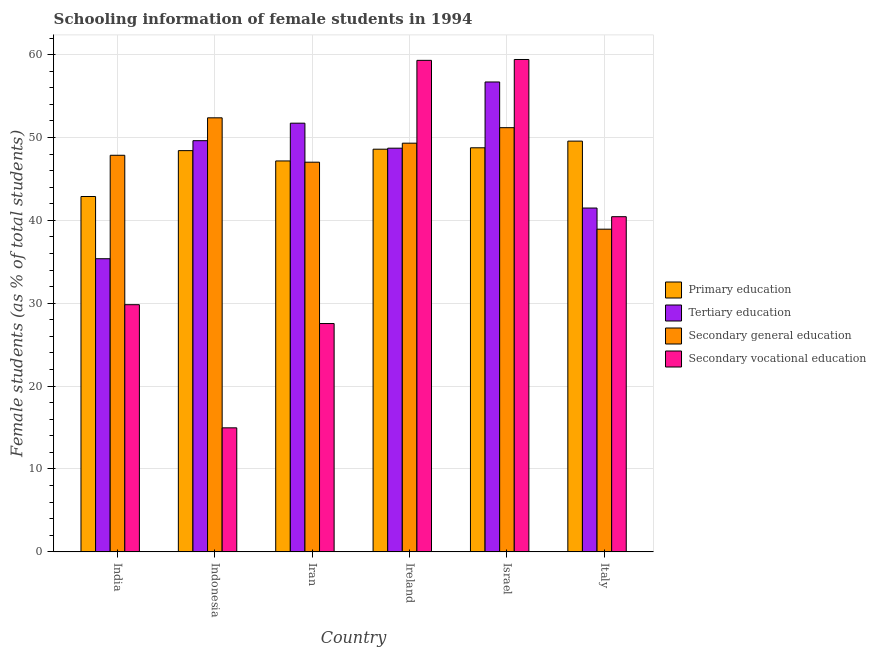How many groups of bars are there?
Offer a very short reply. 6. How many bars are there on the 2nd tick from the left?
Offer a terse response. 4. How many bars are there on the 6th tick from the right?
Offer a terse response. 4. In how many cases, is the number of bars for a given country not equal to the number of legend labels?
Keep it short and to the point. 0. What is the percentage of female students in primary education in Iran?
Your answer should be very brief. 47.17. Across all countries, what is the maximum percentage of female students in secondary vocational education?
Give a very brief answer. 59.41. Across all countries, what is the minimum percentage of female students in primary education?
Make the answer very short. 42.88. In which country was the percentage of female students in tertiary education minimum?
Provide a succinct answer. India. What is the total percentage of female students in primary education in the graph?
Ensure brevity in your answer.  285.38. What is the difference between the percentage of female students in tertiary education in Iran and that in Israel?
Keep it short and to the point. -4.97. What is the difference between the percentage of female students in tertiary education in Indonesia and the percentage of female students in secondary vocational education in Ireland?
Offer a very short reply. -9.69. What is the average percentage of female students in secondary education per country?
Make the answer very short. 47.78. What is the difference between the percentage of female students in tertiary education and percentage of female students in secondary education in Iran?
Offer a very short reply. 4.71. What is the ratio of the percentage of female students in secondary vocational education in Israel to that in Italy?
Your answer should be very brief. 1.47. What is the difference between the highest and the second highest percentage of female students in secondary vocational education?
Your response must be concise. 0.1. What is the difference between the highest and the lowest percentage of female students in tertiary education?
Give a very brief answer. 21.33. In how many countries, is the percentage of female students in secondary vocational education greater than the average percentage of female students in secondary vocational education taken over all countries?
Your answer should be very brief. 3. Is it the case that in every country, the sum of the percentage of female students in tertiary education and percentage of female students in primary education is greater than the sum of percentage of female students in secondary education and percentage of female students in secondary vocational education?
Your response must be concise. No. What does the 3rd bar from the left in India represents?
Offer a very short reply. Secondary general education. What does the 2nd bar from the right in Indonesia represents?
Your answer should be very brief. Secondary general education. Is it the case that in every country, the sum of the percentage of female students in primary education and percentage of female students in tertiary education is greater than the percentage of female students in secondary education?
Your response must be concise. Yes. Are all the bars in the graph horizontal?
Offer a terse response. No. How many countries are there in the graph?
Keep it short and to the point. 6. What is the difference between two consecutive major ticks on the Y-axis?
Offer a very short reply. 10. Are the values on the major ticks of Y-axis written in scientific E-notation?
Your answer should be compact. No. Does the graph contain any zero values?
Make the answer very short. No. How many legend labels are there?
Provide a succinct answer. 4. What is the title of the graph?
Your answer should be compact. Schooling information of female students in 1994. What is the label or title of the X-axis?
Make the answer very short. Country. What is the label or title of the Y-axis?
Keep it short and to the point. Female students (as % of total students). What is the Female students (as % of total students) of Primary education in India?
Ensure brevity in your answer.  42.88. What is the Female students (as % of total students) in Tertiary education in India?
Offer a very short reply. 35.37. What is the Female students (as % of total students) in Secondary general education in India?
Offer a terse response. 47.86. What is the Female students (as % of total students) in Secondary vocational education in India?
Keep it short and to the point. 29.83. What is the Female students (as % of total students) in Primary education in Indonesia?
Offer a very short reply. 48.42. What is the Female students (as % of total students) in Tertiary education in Indonesia?
Give a very brief answer. 49.62. What is the Female students (as % of total students) of Secondary general education in Indonesia?
Provide a short and direct response. 52.38. What is the Female students (as % of total students) of Secondary vocational education in Indonesia?
Your response must be concise. 14.97. What is the Female students (as % of total students) of Primary education in Iran?
Offer a terse response. 47.17. What is the Female students (as % of total students) in Tertiary education in Iran?
Provide a short and direct response. 51.73. What is the Female students (as % of total students) in Secondary general education in Iran?
Your answer should be very brief. 47.02. What is the Female students (as % of total students) in Secondary vocational education in Iran?
Provide a short and direct response. 27.55. What is the Female students (as % of total students) of Primary education in Ireland?
Offer a very short reply. 48.59. What is the Female students (as % of total students) in Tertiary education in Ireland?
Offer a terse response. 48.71. What is the Female students (as % of total students) of Secondary general education in Ireland?
Make the answer very short. 49.31. What is the Female students (as % of total students) in Secondary vocational education in Ireland?
Your answer should be compact. 59.31. What is the Female students (as % of total students) in Primary education in Israel?
Ensure brevity in your answer.  48.76. What is the Female students (as % of total students) of Tertiary education in Israel?
Keep it short and to the point. 56.7. What is the Female students (as % of total students) of Secondary general education in Israel?
Provide a short and direct response. 51.18. What is the Female students (as % of total students) in Secondary vocational education in Israel?
Offer a terse response. 59.41. What is the Female students (as % of total students) of Primary education in Italy?
Provide a succinct answer. 49.56. What is the Female students (as % of total students) of Tertiary education in Italy?
Your answer should be compact. 41.49. What is the Female students (as % of total students) of Secondary general education in Italy?
Provide a short and direct response. 38.94. What is the Female students (as % of total students) of Secondary vocational education in Italy?
Keep it short and to the point. 40.44. Across all countries, what is the maximum Female students (as % of total students) in Primary education?
Make the answer very short. 49.56. Across all countries, what is the maximum Female students (as % of total students) in Tertiary education?
Offer a very short reply. 56.7. Across all countries, what is the maximum Female students (as % of total students) of Secondary general education?
Your answer should be compact. 52.38. Across all countries, what is the maximum Female students (as % of total students) in Secondary vocational education?
Your answer should be compact. 59.41. Across all countries, what is the minimum Female students (as % of total students) in Primary education?
Offer a terse response. 42.88. Across all countries, what is the minimum Female students (as % of total students) in Tertiary education?
Keep it short and to the point. 35.37. Across all countries, what is the minimum Female students (as % of total students) of Secondary general education?
Provide a succinct answer. 38.94. Across all countries, what is the minimum Female students (as % of total students) in Secondary vocational education?
Your answer should be very brief. 14.97. What is the total Female students (as % of total students) of Primary education in the graph?
Offer a terse response. 285.38. What is the total Female students (as % of total students) in Tertiary education in the graph?
Provide a short and direct response. 283.62. What is the total Female students (as % of total students) of Secondary general education in the graph?
Keep it short and to the point. 286.69. What is the total Female students (as % of total students) in Secondary vocational education in the graph?
Your answer should be very brief. 231.51. What is the difference between the Female students (as % of total students) in Primary education in India and that in Indonesia?
Your answer should be compact. -5.54. What is the difference between the Female students (as % of total students) in Tertiary education in India and that in Indonesia?
Give a very brief answer. -14.24. What is the difference between the Female students (as % of total students) of Secondary general education in India and that in Indonesia?
Provide a succinct answer. -4.52. What is the difference between the Female students (as % of total students) of Secondary vocational education in India and that in Indonesia?
Provide a short and direct response. 14.86. What is the difference between the Female students (as % of total students) in Primary education in India and that in Iran?
Give a very brief answer. -4.29. What is the difference between the Female students (as % of total students) in Tertiary education in India and that in Iran?
Offer a very short reply. -16.36. What is the difference between the Female students (as % of total students) of Secondary general education in India and that in Iran?
Offer a very short reply. 0.84. What is the difference between the Female students (as % of total students) of Secondary vocational education in India and that in Iran?
Ensure brevity in your answer.  2.27. What is the difference between the Female students (as % of total students) of Primary education in India and that in Ireland?
Provide a succinct answer. -5.71. What is the difference between the Female students (as % of total students) in Tertiary education in India and that in Ireland?
Ensure brevity in your answer.  -13.34. What is the difference between the Female students (as % of total students) of Secondary general education in India and that in Ireland?
Ensure brevity in your answer.  -1.46. What is the difference between the Female students (as % of total students) of Secondary vocational education in India and that in Ireland?
Give a very brief answer. -29.48. What is the difference between the Female students (as % of total students) in Primary education in India and that in Israel?
Your answer should be very brief. -5.88. What is the difference between the Female students (as % of total students) in Tertiary education in India and that in Israel?
Provide a short and direct response. -21.33. What is the difference between the Female students (as % of total students) in Secondary general education in India and that in Israel?
Offer a terse response. -3.33. What is the difference between the Female students (as % of total students) in Secondary vocational education in India and that in Israel?
Make the answer very short. -29.59. What is the difference between the Female students (as % of total students) in Primary education in India and that in Italy?
Offer a very short reply. -6.68. What is the difference between the Female students (as % of total students) in Tertiary education in India and that in Italy?
Keep it short and to the point. -6.12. What is the difference between the Female students (as % of total students) of Secondary general education in India and that in Italy?
Keep it short and to the point. 8.92. What is the difference between the Female students (as % of total students) in Secondary vocational education in India and that in Italy?
Offer a very short reply. -10.62. What is the difference between the Female students (as % of total students) of Primary education in Indonesia and that in Iran?
Give a very brief answer. 1.24. What is the difference between the Female students (as % of total students) of Tertiary education in Indonesia and that in Iran?
Give a very brief answer. -2.11. What is the difference between the Female students (as % of total students) in Secondary general education in Indonesia and that in Iran?
Your answer should be compact. 5.36. What is the difference between the Female students (as % of total students) in Secondary vocational education in Indonesia and that in Iran?
Provide a short and direct response. -12.59. What is the difference between the Female students (as % of total students) in Primary education in Indonesia and that in Ireland?
Offer a very short reply. -0.17. What is the difference between the Female students (as % of total students) of Tertiary education in Indonesia and that in Ireland?
Offer a terse response. 0.9. What is the difference between the Female students (as % of total students) in Secondary general education in Indonesia and that in Ireland?
Provide a succinct answer. 3.06. What is the difference between the Female students (as % of total students) of Secondary vocational education in Indonesia and that in Ireland?
Your answer should be very brief. -44.34. What is the difference between the Female students (as % of total students) in Primary education in Indonesia and that in Israel?
Provide a short and direct response. -0.34. What is the difference between the Female students (as % of total students) in Tertiary education in Indonesia and that in Israel?
Your answer should be compact. -7.08. What is the difference between the Female students (as % of total students) in Secondary general education in Indonesia and that in Israel?
Your response must be concise. 1.19. What is the difference between the Female students (as % of total students) in Secondary vocational education in Indonesia and that in Israel?
Make the answer very short. -44.45. What is the difference between the Female students (as % of total students) in Primary education in Indonesia and that in Italy?
Ensure brevity in your answer.  -1.15. What is the difference between the Female students (as % of total students) of Tertiary education in Indonesia and that in Italy?
Your answer should be compact. 8.13. What is the difference between the Female students (as % of total students) of Secondary general education in Indonesia and that in Italy?
Your answer should be very brief. 13.44. What is the difference between the Female students (as % of total students) in Secondary vocational education in Indonesia and that in Italy?
Provide a succinct answer. -25.48. What is the difference between the Female students (as % of total students) of Primary education in Iran and that in Ireland?
Your answer should be very brief. -1.42. What is the difference between the Female students (as % of total students) in Tertiary education in Iran and that in Ireland?
Ensure brevity in your answer.  3.02. What is the difference between the Female students (as % of total students) of Secondary general education in Iran and that in Ireland?
Your answer should be very brief. -2.29. What is the difference between the Female students (as % of total students) of Secondary vocational education in Iran and that in Ireland?
Your answer should be compact. -31.76. What is the difference between the Female students (as % of total students) in Primary education in Iran and that in Israel?
Keep it short and to the point. -1.59. What is the difference between the Female students (as % of total students) in Tertiary education in Iran and that in Israel?
Provide a succinct answer. -4.97. What is the difference between the Female students (as % of total students) of Secondary general education in Iran and that in Israel?
Your response must be concise. -4.16. What is the difference between the Female students (as % of total students) in Secondary vocational education in Iran and that in Israel?
Ensure brevity in your answer.  -31.86. What is the difference between the Female students (as % of total students) in Primary education in Iran and that in Italy?
Your answer should be compact. -2.39. What is the difference between the Female students (as % of total students) of Tertiary education in Iran and that in Italy?
Ensure brevity in your answer.  10.24. What is the difference between the Female students (as % of total students) in Secondary general education in Iran and that in Italy?
Your response must be concise. 8.08. What is the difference between the Female students (as % of total students) in Secondary vocational education in Iran and that in Italy?
Make the answer very short. -12.89. What is the difference between the Female students (as % of total students) in Primary education in Ireland and that in Israel?
Make the answer very short. -0.17. What is the difference between the Female students (as % of total students) in Tertiary education in Ireland and that in Israel?
Your response must be concise. -7.99. What is the difference between the Female students (as % of total students) in Secondary general education in Ireland and that in Israel?
Give a very brief answer. -1.87. What is the difference between the Female students (as % of total students) in Secondary vocational education in Ireland and that in Israel?
Provide a short and direct response. -0.1. What is the difference between the Female students (as % of total students) in Primary education in Ireland and that in Italy?
Ensure brevity in your answer.  -0.97. What is the difference between the Female students (as % of total students) of Tertiary education in Ireland and that in Italy?
Keep it short and to the point. 7.22. What is the difference between the Female students (as % of total students) in Secondary general education in Ireland and that in Italy?
Your answer should be very brief. 10.38. What is the difference between the Female students (as % of total students) of Secondary vocational education in Ireland and that in Italy?
Keep it short and to the point. 18.86. What is the difference between the Female students (as % of total students) in Primary education in Israel and that in Italy?
Give a very brief answer. -0.81. What is the difference between the Female students (as % of total students) of Tertiary education in Israel and that in Italy?
Offer a very short reply. 15.21. What is the difference between the Female students (as % of total students) in Secondary general education in Israel and that in Italy?
Ensure brevity in your answer.  12.25. What is the difference between the Female students (as % of total students) of Secondary vocational education in Israel and that in Italy?
Your answer should be very brief. 18.97. What is the difference between the Female students (as % of total students) in Primary education in India and the Female students (as % of total students) in Tertiary education in Indonesia?
Ensure brevity in your answer.  -6.74. What is the difference between the Female students (as % of total students) in Primary education in India and the Female students (as % of total students) in Secondary general education in Indonesia?
Provide a succinct answer. -9.5. What is the difference between the Female students (as % of total students) in Primary education in India and the Female students (as % of total students) in Secondary vocational education in Indonesia?
Offer a terse response. 27.91. What is the difference between the Female students (as % of total students) in Tertiary education in India and the Female students (as % of total students) in Secondary general education in Indonesia?
Your answer should be compact. -17. What is the difference between the Female students (as % of total students) in Tertiary education in India and the Female students (as % of total students) in Secondary vocational education in Indonesia?
Make the answer very short. 20.41. What is the difference between the Female students (as % of total students) in Secondary general education in India and the Female students (as % of total students) in Secondary vocational education in Indonesia?
Offer a very short reply. 32.89. What is the difference between the Female students (as % of total students) of Primary education in India and the Female students (as % of total students) of Tertiary education in Iran?
Ensure brevity in your answer.  -8.85. What is the difference between the Female students (as % of total students) in Primary education in India and the Female students (as % of total students) in Secondary general education in Iran?
Ensure brevity in your answer.  -4.14. What is the difference between the Female students (as % of total students) in Primary education in India and the Female students (as % of total students) in Secondary vocational education in Iran?
Keep it short and to the point. 15.33. What is the difference between the Female students (as % of total students) of Tertiary education in India and the Female students (as % of total students) of Secondary general education in Iran?
Ensure brevity in your answer.  -11.65. What is the difference between the Female students (as % of total students) of Tertiary education in India and the Female students (as % of total students) of Secondary vocational education in Iran?
Make the answer very short. 7.82. What is the difference between the Female students (as % of total students) in Secondary general education in India and the Female students (as % of total students) in Secondary vocational education in Iran?
Provide a short and direct response. 20.3. What is the difference between the Female students (as % of total students) of Primary education in India and the Female students (as % of total students) of Tertiary education in Ireland?
Offer a terse response. -5.83. What is the difference between the Female students (as % of total students) of Primary education in India and the Female students (as % of total students) of Secondary general education in Ireland?
Offer a terse response. -6.43. What is the difference between the Female students (as % of total students) of Primary education in India and the Female students (as % of total students) of Secondary vocational education in Ireland?
Provide a short and direct response. -16.43. What is the difference between the Female students (as % of total students) of Tertiary education in India and the Female students (as % of total students) of Secondary general education in Ireland?
Your answer should be compact. -13.94. What is the difference between the Female students (as % of total students) of Tertiary education in India and the Female students (as % of total students) of Secondary vocational education in Ireland?
Provide a succinct answer. -23.94. What is the difference between the Female students (as % of total students) in Secondary general education in India and the Female students (as % of total students) in Secondary vocational education in Ireland?
Keep it short and to the point. -11.45. What is the difference between the Female students (as % of total students) of Primary education in India and the Female students (as % of total students) of Tertiary education in Israel?
Offer a terse response. -13.82. What is the difference between the Female students (as % of total students) in Primary education in India and the Female students (as % of total students) in Secondary general education in Israel?
Provide a short and direct response. -8.3. What is the difference between the Female students (as % of total students) of Primary education in India and the Female students (as % of total students) of Secondary vocational education in Israel?
Provide a succinct answer. -16.53. What is the difference between the Female students (as % of total students) of Tertiary education in India and the Female students (as % of total students) of Secondary general education in Israel?
Provide a succinct answer. -15.81. What is the difference between the Female students (as % of total students) in Tertiary education in India and the Female students (as % of total students) in Secondary vocational education in Israel?
Keep it short and to the point. -24.04. What is the difference between the Female students (as % of total students) of Secondary general education in India and the Female students (as % of total students) of Secondary vocational education in Israel?
Ensure brevity in your answer.  -11.56. What is the difference between the Female students (as % of total students) in Primary education in India and the Female students (as % of total students) in Tertiary education in Italy?
Provide a short and direct response. 1.39. What is the difference between the Female students (as % of total students) of Primary education in India and the Female students (as % of total students) of Secondary general education in Italy?
Your response must be concise. 3.94. What is the difference between the Female students (as % of total students) of Primary education in India and the Female students (as % of total students) of Secondary vocational education in Italy?
Your answer should be compact. 2.44. What is the difference between the Female students (as % of total students) in Tertiary education in India and the Female students (as % of total students) in Secondary general education in Italy?
Provide a succinct answer. -3.56. What is the difference between the Female students (as % of total students) in Tertiary education in India and the Female students (as % of total students) in Secondary vocational education in Italy?
Make the answer very short. -5.07. What is the difference between the Female students (as % of total students) in Secondary general education in India and the Female students (as % of total students) in Secondary vocational education in Italy?
Offer a terse response. 7.41. What is the difference between the Female students (as % of total students) of Primary education in Indonesia and the Female students (as % of total students) of Tertiary education in Iran?
Offer a very short reply. -3.31. What is the difference between the Female students (as % of total students) of Primary education in Indonesia and the Female students (as % of total students) of Secondary general education in Iran?
Provide a short and direct response. 1.4. What is the difference between the Female students (as % of total students) of Primary education in Indonesia and the Female students (as % of total students) of Secondary vocational education in Iran?
Offer a terse response. 20.86. What is the difference between the Female students (as % of total students) in Tertiary education in Indonesia and the Female students (as % of total students) in Secondary general education in Iran?
Your response must be concise. 2.6. What is the difference between the Female students (as % of total students) in Tertiary education in Indonesia and the Female students (as % of total students) in Secondary vocational education in Iran?
Ensure brevity in your answer.  22.06. What is the difference between the Female students (as % of total students) in Secondary general education in Indonesia and the Female students (as % of total students) in Secondary vocational education in Iran?
Give a very brief answer. 24.82. What is the difference between the Female students (as % of total students) in Primary education in Indonesia and the Female students (as % of total students) in Tertiary education in Ireland?
Give a very brief answer. -0.3. What is the difference between the Female students (as % of total students) of Primary education in Indonesia and the Female students (as % of total students) of Secondary general education in Ireland?
Your answer should be very brief. -0.9. What is the difference between the Female students (as % of total students) in Primary education in Indonesia and the Female students (as % of total students) in Secondary vocational education in Ireland?
Offer a terse response. -10.89. What is the difference between the Female students (as % of total students) of Tertiary education in Indonesia and the Female students (as % of total students) of Secondary general education in Ireland?
Provide a succinct answer. 0.3. What is the difference between the Female students (as % of total students) in Tertiary education in Indonesia and the Female students (as % of total students) in Secondary vocational education in Ireland?
Keep it short and to the point. -9.69. What is the difference between the Female students (as % of total students) in Secondary general education in Indonesia and the Female students (as % of total students) in Secondary vocational education in Ireland?
Provide a short and direct response. -6.93. What is the difference between the Female students (as % of total students) of Primary education in Indonesia and the Female students (as % of total students) of Tertiary education in Israel?
Make the answer very short. -8.28. What is the difference between the Female students (as % of total students) of Primary education in Indonesia and the Female students (as % of total students) of Secondary general education in Israel?
Your response must be concise. -2.77. What is the difference between the Female students (as % of total students) of Primary education in Indonesia and the Female students (as % of total students) of Secondary vocational education in Israel?
Your response must be concise. -11. What is the difference between the Female students (as % of total students) of Tertiary education in Indonesia and the Female students (as % of total students) of Secondary general education in Israel?
Your answer should be compact. -1.57. What is the difference between the Female students (as % of total students) in Tertiary education in Indonesia and the Female students (as % of total students) in Secondary vocational education in Israel?
Offer a terse response. -9.8. What is the difference between the Female students (as % of total students) of Secondary general education in Indonesia and the Female students (as % of total students) of Secondary vocational education in Israel?
Provide a succinct answer. -7.04. What is the difference between the Female students (as % of total students) in Primary education in Indonesia and the Female students (as % of total students) in Tertiary education in Italy?
Keep it short and to the point. 6.93. What is the difference between the Female students (as % of total students) in Primary education in Indonesia and the Female students (as % of total students) in Secondary general education in Italy?
Your response must be concise. 9.48. What is the difference between the Female students (as % of total students) of Primary education in Indonesia and the Female students (as % of total students) of Secondary vocational education in Italy?
Keep it short and to the point. 7.97. What is the difference between the Female students (as % of total students) in Tertiary education in Indonesia and the Female students (as % of total students) in Secondary general education in Italy?
Provide a succinct answer. 10.68. What is the difference between the Female students (as % of total students) in Tertiary education in Indonesia and the Female students (as % of total students) in Secondary vocational education in Italy?
Your response must be concise. 9.17. What is the difference between the Female students (as % of total students) of Secondary general education in Indonesia and the Female students (as % of total students) of Secondary vocational education in Italy?
Give a very brief answer. 11.93. What is the difference between the Female students (as % of total students) of Primary education in Iran and the Female students (as % of total students) of Tertiary education in Ireland?
Your answer should be compact. -1.54. What is the difference between the Female students (as % of total students) in Primary education in Iran and the Female students (as % of total students) in Secondary general education in Ireland?
Ensure brevity in your answer.  -2.14. What is the difference between the Female students (as % of total students) of Primary education in Iran and the Female students (as % of total students) of Secondary vocational education in Ireland?
Offer a terse response. -12.14. What is the difference between the Female students (as % of total students) in Tertiary education in Iran and the Female students (as % of total students) in Secondary general education in Ireland?
Offer a very short reply. 2.41. What is the difference between the Female students (as % of total students) in Tertiary education in Iran and the Female students (as % of total students) in Secondary vocational education in Ireland?
Provide a succinct answer. -7.58. What is the difference between the Female students (as % of total students) of Secondary general education in Iran and the Female students (as % of total students) of Secondary vocational education in Ireland?
Provide a succinct answer. -12.29. What is the difference between the Female students (as % of total students) in Primary education in Iran and the Female students (as % of total students) in Tertiary education in Israel?
Your answer should be compact. -9.53. What is the difference between the Female students (as % of total students) of Primary education in Iran and the Female students (as % of total students) of Secondary general education in Israel?
Keep it short and to the point. -4.01. What is the difference between the Female students (as % of total students) of Primary education in Iran and the Female students (as % of total students) of Secondary vocational education in Israel?
Provide a short and direct response. -12.24. What is the difference between the Female students (as % of total students) of Tertiary education in Iran and the Female students (as % of total students) of Secondary general education in Israel?
Provide a succinct answer. 0.54. What is the difference between the Female students (as % of total students) in Tertiary education in Iran and the Female students (as % of total students) in Secondary vocational education in Israel?
Ensure brevity in your answer.  -7.68. What is the difference between the Female students (as % of total students) of Secondary general education in Iran and the Female students (as % of total students) of Secondary vocational education in Israel?
Your answer should be very brief. -12.39. What is the difference between the Female students (as % of total students) of Primary education in Iran and the Female students (as % of total students) of Tertiary education in Italy?
Your answer should be very brief. 5.68. What is the difference between the Female students (as % of total students) of Primary education in Iran and the Female students (as % of total students) of Secondary general education in Italy?
Offer a very short reply. 8.23. What is the difference between the Female students (as % of total students) of Primary education in Iran and the Female students (as % of total students) of Secondary vocational education in Italy?
Your answer should be compact. 6.73. What is the difference between the Female students (as % of total students) in Tertiary education in Iran and the Female students (as % of total students) in Secondary general education in Italy?
Provide a succinct answer. 12.79. What is the difference between the Female students (as % of total students) of Tertiary education in Iran and the Female students (as % of total students) of Secondary vocational education in Italy?
Your answer should be very brief. 11.28. What is the difference between the Female students (as % of total students) of Secondary general education in Iran and the Female students (as % of total students) of Secondary vocational education in Italy?
Make the answer very short. 6.58. What is the difference between the Female students (as % of total students) in Primary education in Ireland and the Female students (as % of total students) in Tertiary education in Israel?
Your answer should be very brief. -8.11. What is the difference between the Female students (as % of total students) in Primary education in Ireland and the Female students (as % of total students) in Secondary general education in Israel?
Provide a short and direct response. -2.6. What is the difference between the Female students (as % of total students) of Primary education in Ireland and the Female students (as % of total students) of Secondary vocational education in Israel?
Provide a succinct answer. -10.82. What is the difference between the Female students (as % of total students) of Tertiary education in Ireland and the Female students (as % of total students) of Secondary general education in Israel?
Make the answer very short. -2.47. What is the difference between the Female students (as % of total students) of Tertiary education in Ireland and the Female students (as % of total students) of Secondary vocational education in Israel?
Your answer should be compact. -10.7. What is the difference between the Female students (as % of total students) in Secondary general education in Ireland and the Female students (as % of total students) in Secondary vocational education in Israel?
Your answer should be compact. -10.1. What is the difference between the Female students (as % of total students) of Primary education in Ireland and the Female students (as % of total students) of Tertiary education in Italy?
Your answer should be compact. 7.1. What is the difference between the Female students (as % of total students) of Primary education in Ireland and the Female students (as % of total students) of Secondary general education in Italy?
Offer a terse response. 9.65. What is the difference between the Female students (as % of total students) in Primary education in Ireland and the Female students (as % of total students) in Secondary vocational education in Italy?
Your response must be concise. 8.14. What is the difference between the Female students (as % of total students) in Tertiary education in Ireland and the Female students (as % of total students) in Secondary general education in Italy?
Your response must be concise. 9.78. What is the difference between the Female students (as % of total students) in Tertiary education in Ireland and the Female students (as % of total students) in Secondary vocational education in Italy?
Offer a terse response. 8.27. What is the difference between the Female students (as % of total students) in Secondary general education in Ireland and the Female students (as % of total students) in Secondary vocational education in Italy?
Make the answer very short. 8.87. What is the difference between the Female students (as % of total students) of Primary education in Israel and the Female students (as % of total students) of Tertiary education in Italy?
Make the answer very short. 7.27. What is the difference between the Female students (as % of total students) of Primary education in Israel and the Female students (as % of total students) of Secondary general education in Italy?
Your answer should be very brief. 9.82. What is the difference between the Female students (as % of total students) in Primary education in Israel and the Female students (as % of total students) in Secondary vocational education in Italy?
Your answer should be very brief. 8.31. What is the difference between the Female students (as % of total students) in Tertiary education in Israel and the Female students (as % of total students) in Secondary general education in Italy?
Keep it short and to the point. 17.76. What is the difference between the Female students (as % of total students) of Tertiary education in Israel and the Female students (as % of total students) of Secondary vocational education in Italy?
Provide a succinct answer. 16.25. What is the difference between the Female students (as % of total students) of Secondary general education in Israel and the Female students (as % of total students) of Secondary vocational education in Italy?
Your response must be concise. 10.74. What is the average Female students (as % of total students) of Primary education per country?
Offer a terse response. 47.56. What is the average Female students (as % of total students) in Tertiary education per country?
Ensure brevity in your answer.  47.27. What is the average Female students (as % of total students) of Secondary general education per country?
Offer a very short reply. 47.78. What is the average Female students (as % of total students) in Secondary vocational education per country?
Ensure brevity in your answer.  38.59. What is the difference between the Female students (as % of total students) in Primary education and Female students (as % of total students) in Tertiary education in India?
Your answer should be very brief. 7.51. What is the difference between the Female students (as % of total students) of Primary education and Female students (as % of total students) of Secondary general education in India?
Give a very brief answer. -4.98. What is the difference between the Female students (as % of total students) of Primary education and Female students (as % of total students) of Secondary vocational education in India?
Offer a very short reply. 13.05. What is the difference between the Female students (as % of total students) in Tertiary education and Female students (as % of total students) in Secondary general education in India?
Ensure brevity in your answer.  -12.48. What is the difference between the Female students (as % of total students) in Tertiary education and Female students (as % of total students) in Secondary vocational education in India?
Make the answer very short. 5.55. What is the difference between the Female students (as % of total students) in Secondary general education and Female students (as % of total students) in Secondary vocational education in India?
Give a very brief answer. 18.03. What is the difference between the Female students (as % of total students) of Primary education and Female students (as % of total students) of Tertiary education in Indonesia?
Keep it short and to the point. -1.2. What is the difference between the Female students (as % of total students) in Primary education and Female students (as % of total students) in Secondary general education in Indonesia?
Ensure brevity in your answer.  -3.96. What is the difference between the Female students (as % of total students) in Primary education and Female students (as % of total students) in Secondary vocational education in Indonesia?
Your answer should be very brief. 33.45. What is the difference between the Female students (as % of total students) of Tertiary education and Female students (as % of total students) of Secondary general education in Indonesia?
Make the answer very short. -2.76. What is the difference between the Female students (as % of total students) in Tertiary education and Female students (as % of total students) in Secondary vocational education in Indonesia?
Offer a very short reply. 34.65. What is the difference between the Female students (as % of total students) of Secondary general education and Female students (as % of total students) of Secondary vocational education in Indonesia?
Ensure brevity in your answer.  37.41. What is the difference between the Female students (as % of total students) in Primary education and Female students (as % of total students) in Tertiary education in Iran?
Offer a very short reply. -4.56. What is the difference between the Female students (as % of total students) of Primary education and Female students (as % of total students) of Secondary general education in Iran?
Your response must be concise. 0.15. What is the difference between the Female students (as % of total students) of Primary education and Female students (as % of total students) of Secondary vocational education in Iran?
Provide a succinct answer. 19.62. What is the difference between the Female students (as % of total students) of Tertiary education and Female students (as % of total students) of Secondary general education in Iran?
Offer a very short reply. 4.71. What is the difference between the Female students (as % of total students) in Tertiary education and Female students (as % of total students) in Secondary vocational education in Iran?
Give a very brief answer. 24.18. What is the difference between the Female students (as % of total students) in Secondary general education and Female students (as % of total students) in Secondary vocational education in Iran?
Offer a very short reply. 19.47. What is the difference between the Female students (as % of total students) of Primary education and Female students (as % of total students) of Tertiary education in Ireland?
Your response must be concise. -0.12. What is the difference between the Female students (as % of total students) of Primary education and Female students (as % of total students) of Secondary general education in Ireland?
Your answer should be very brief. -0.73. What is the difference between the Female students (as % of total students) in Primary education and Female students (as % of total students) in Secondary vocational education in Ireland?
Offer a terse response. -10.72. What is the difference between the Female students (as % of total students) of Tertiary education and Female students (as % of total students) of Secondary general education in Ireland?
Provide a succinct answer. -0.6. What is the difference between the Female students (as % of total students) in Tertiary education and Female students (as % of total students) in Secondary vocational education in Ireland?
Ensure brevity in your answer.  -10.6. What is the difference between the Female students (as % of total students) in Secondary general education and Female students (as % of total students) in Secondary vocational education in Ireland?
Make the answer very short. -9.99. What is the difference between the Female students (as % of total students) of Primary education and Female students (as % of total students) of Tertiary education in Israel?
Ensure brevity in your answer.  -7.94. What is the difference between the Female students (as % of total students) in Primary education and Female students (as % of total students) in Secondary general education in Israel?
Provide a short and direct response. -2.43. What is the difference between the Female students (as % of total students) in Primary education and Female students (as % of total students) in Secondary vocational education in Israel?
Your answer should be compact. -10.65. What is the difference between the Female students (as % of total students) in Tertiary education and Female students (as % of total students) in Secondary general education in Israel?
Your answer should be very brief. 5.51. What is the difference between the Female students (as % of total students) in Tertiary education and Female students (as % of total students) in Secondary vocational education in Israel?
Provide a succinct answer. -2.71. What is the difference between the Female students (as % of total students) in Secondary general education and Female students (as % of total students) in Secondary vocational education in Israel?
Your answer should be compact. -8.23. What is the difference between the Female students (as % of total students) in Primary education and Female students (as % of total students) in Tertiary education in Italy?
Provide a succinct answer. 8.07. What is the difference between the Female students (as % of total students) of Primary education and Female students (as % of total students) of Secondary general education in Italy?
Your response must be concise. 10.63. What is the difference between the Female students (as % of total students) of Primary education and Female students (as % of total students) of Secondary vocational education in Italy?
Provide a short and direct response. 9.12. What is the difference between the Female students (as % of total students) in Tertiary education and Female students (as % of total students) in Secondary general education in Italy?
Your answer should be very brief. 2.55. What is the difference between the Female students (as % of total students) of Tertiary education and Female students (as % of total students) of Secondary vocational education in Italy?
Give a very brief answer. 1.05. What is the difference between the Female students (as % of total students) of Secondary general education and Female students (as % of total students) of Secondary vocational education in Italy?
Give a very brief answer. -1.51. What is the ratio of the Female students (as % of total students) of Primary education in India to that in Indonesia?
Your response must be concise. 0.89. What is the ratio of the Female students (as % of total students) of Tertiary education in India to that in Indonesia?
Provide a short and direct response. 0.71. What is the ratio of the Female students (as % of total students) in Secondary general education in India to that in Indonesia?
Your answer should be very brief. 0.91. What is the ratio of the Female students (as % of total students) of Secondary vocational education in India to that in Indonesia?
Make the answer very short. 1.99. What is the ratio of the Female students (as % of total students) in Primary education in India to that in Iran?
Make the answer very short. 0.91. What is the ratio of the Female students (as % of total students) of Tertiary education in India to that in Iran?
Provide a short and direct response. 0.68. What is the ratio of the Female students (as % of total students) in Secondary general education in India to that in Iran?
Your response must be concise. 1.02. What is the ratio of the Female students (as % of total students) in Secondary vocational education in India to that in Iran?
Provide a short and direct response. 1.08. What is the ratio of the Female students (as % of total students) of Primary education in India to that in Ireland?
Keep it short and to the point. 0.88. What is the ratio of the Female students (as % of total students) in Tertiary education in India to that in Ireland?
Offer a terse response. 0.73. What is the ratio of the Female students (as % of total students) in Secondary general education in India to that in Ireland?
Offer a very short reply. 0.97. What is the ratio of the Female students (as % of total students) in Secondary vocational education in India to that in Ireland?
Give a very brief answer. 0.5. What is the ratio of the Female students (as % of total students) of Primary education in India to that in Israel?
Keep it short and to the point. 0.88. What is the ratio of the Female students (as % of total students) of Tertiary education in India to that in Israel?
Give a very brief answer. 0.62. What is the ratio of the Female students (as % of total students) of Secondary general education in India to that in Israel?
Provide a short and direct response. 0.94. What is the ratio of the Female students (as % of total students) in Secondary vocational education in India to that in Israel?
Provide a succinct answer. 0.5. What is the ratio of the Female students (as % of total students) in Primary education in India to that in Italy?
Keep it short and to the point. 0.87. What is the ratio of the Female students (as % of total students) in Tertiary education in India to that in Italy?
Provide a succinct answer. 0.85. What is the ratio of the Female students (as % of total students) in Secondary general education in India to that in Italy?
Make the answer very short. 1.23. What is the ratio of the Female students (as % of total students) in Secondary vocational education in India to that in Italy?
Offer a very short reply. 0.74. What is the ratio of the Female students (as % of total students) in Primary education in Indonesia to that in Iran?
Offer a terse response. 1.03. What is the ratio of the Female students (as % of total students) in Tertiary education in Indonesia to that in Iran?
Your answer should be very brief. 0.96. What is the ratio of the Female students (as % of total students) of Secondary general education in Indonesia to that in Iran?
Provide a succinct answer. 1.11. What is the ratio of the Female students (as % of total students) in Secondary vocational education in Indonesia to that in Iran?
Offer a very short reply. 0.54. What is the ratio of the Female students (as % of total students) of Tertiary education in Indonesia to that in Ireland?
Give a very brief answer. 1.02. What is the ratio of the Female students (as % of total students) of Secondary general education in Indonesia to that in Ireland?
Keep it short and to the point. 1.06. What is the ratio of the Female students (as % of total students) in Secondary vocational education in Indonesia to that in Ireland?
Offer a terse response. 0.25. What is the ratio of the Female students (as % of total students) in Tertiary education in Indonesia to that in Israel?
Provide a short and direct response. 0.88. What is the ratio of the Female students (as % of total students) in Secondary general education in Indonesia to that in Israel?
Your answer should be very brief. 1.02. What is the ratio of the Female students (as % of total students) of Secondary vocational education in Indonesia to that in Israel?
Offer a terse response. 0.25. What is the ratio of the Female students (as % of total students) of Primary education in Indonesia to that in Italy?
Make the answer very short. 0.98. What is the ratio of the Female students (as % of total students) of Tertiary education in Indonesia to that in Italy?
Your answer should be very brief. 1.2. What is the ratio of the Female students (as % of total students) in Secondary general education in Indonesia to that in Italy?
Your response must be concise. 1.35. What is the ratio of the Female students (as % of total students) of Secondary vocational education in Indonesia to that in Italy?
Ensure brevity in your answer.  0.37. What is the ratio of the Female students (as % of total students) of Primary education in Iran to that in Ireland?
Your answer should be compact. 0.97. What is the ratio of the Female students (as % of total students) in Tertiary education in Iran to that in Ireland?
Ensure brevity in your answer.  1.06. What is the ratio of the Female students (as % of total students) in Secondary general education in Iran to that in Ireland?
Provide a short and direct response. 0.95. What is the ratio of the Female students (as % of total students) in Secondary vocational education in Iran to that in Ireland?
Make the answer very short. 0.46. What is the ratio of the Female students (as % of total students) of Primary education in Iran to that in Israel?
Give a very brief answer. 0.97. What is the ratio of the Female students (as % of total students) of Tertiary education in Iran to that in Israel?
Your answer should be compact. 0.91. What is the ratio of the Female students (as % of total students) in Secondary general education in Iran to that in Israel?
Your response must be concise. 0.92. What is the ratio of the Female students (as % of total students) in Secondary vocational education in Iran to that in Israel?
Ensure brevity in your answer.  0.46. What is the ratio of the Female students (as % of total students) of Primary education in Iran to that in Italy?
Your answer should be very brief. 0.95. What is the ratio of the Female students (as % of total students) of Tertiary education in Iran to that in Italy?
Provide a succinct answer. 1.25. What is the ratio of the Female students (as % of total students) of Secondary general education in Iran to that in Italy?
Provide a short and direct response. 1.21. What is the ratio of the Female students (as % of total students) of Secondary vocational education in Iran to that in Italy?
Make the answer very short. 0.68. What is the ratio of the Female students (as % of total students) in Primary education in Ireland to that in Israel?
Make the answer very short. 1. What is the ratio of the Female students (as % of total students) of Tertiary education in Ireland to that in Israel?
Offer a very short reply. 0.86. What is the ratio of the Female students (as % of total students) of Secondary general education in Ireland to that in Israel?
Your answer should be compact. 0.96. What is the ratio of the Female students (as % of total students) of Secondary vocational education in Ireland to that in Israel?
Make the answer very short. 1. What is the ratio of the Female students (as % of total students) of Primary education in Ireland to that in Italy?
Keep it short and to the point. 0.98. What is the ratio of the Female students (as % of total students) of Tertiary education in Ireland to that in Italy?
Offer a terse response. 1.17. What is the ratio of the Female students (as % of total students) in Secondary general education in Ireland to that in Italy?
Offer a terse response. 1.27. What is the ratio of the Female students (as % of total students) of Secondary vocational education in Ireland to that in Italy?
Provide a succinct answer. 1.47. What is the ratio of the Female students (as % of total students) of Primary education in Israel to that in Italy?
Keep it short and to the point. 0.98. What is the ratio of the Female students (as % of total students) in Tertiary education in Israel to that in Italy?
Your answer should be very brief. 1.37. What is the ratio of the Female students (as % of total students) in Secondary general education in Israel to that in Italy?
Provide a succinct answer. 1.31. What is the ratio of the Female students (as % of total students) in Secondary vocational education in Israel to that in Italy?
Provide a short and direct response. 1.47. What is the difference between the highest and the second highest Female students (as % of total students) of Primary education?
Keep it short and to the point. 0.81. What is the difference between the highest and the second highest Female students (as % of total students) in Tertiary education?
Keep it short and to the point. 4.97. What is the difference between the highest and the second highest Female students (as % of total students) in Secondary general education?
Offer a terse response. 1.19. What is the difference between the highest and the second highest Female students (as % of total students) in Secondary vocational education?
Your response must be concise. 0.1. What is the difference between the highest and the lowest Female students (as % of total students) of Primary education?
Give a very brief answer. 6.68. What is the difference between the highest and the lowest Female students (as % of total students) in Tertiary education?
Ensure brevity in your answer.  21.33. What is the difference between the highest and the lowest Female students (as % of total students) in Secondary general education?
Provide a short and direct response. 13.44. What is the difference between the highest and the lowest Female students (as % of total students) of Secondary vocational education?
Offer a terse response. 44.45. 